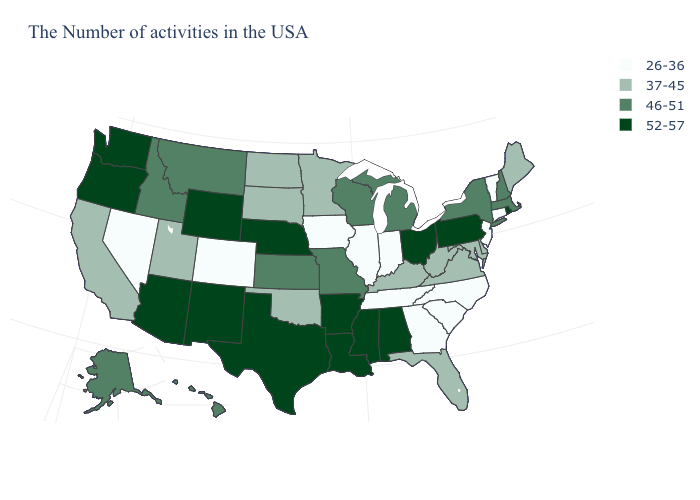What is the value of Wisconsin?
Keep it brief. 46-51. Does Maine have the same value as Kentucky?
Give a very brief answer. Yes. Does Nevada have the lowest value in the USA?
Quick response, please. Yes. What is the highest value in the MidWest ?
Keep it brief. 52-57. What is the value of Delaware?
Quick response, please. 37-45. Name the states that have a value in the range 52-57?
Short answer required. Rhode Island, Pennsylvania, Ohio, Alabama, Mississippi, Louisiana, Arkansas, Nebraska, Texas, Wyoming, New Mexico, Arizona, Washington, Oregon. What is the value of Illinois?
Concise answer only. 26-36. What is the value of Iowa?
Give a very brief answer. 26-36. What is the value of Virginia?
Keep it brief. 37-45. Does the first symbol in the legend represent the smallest category?
Be succinct. Yes. Name the states that have a value in the range 37-45?
Keep it brief. Maine, Delaware, Maryland, Virginia, West Virginia, Florida, Kentucky, Minnesota, Oklahoma, South Dakota, North Dakota, Utah, California. What is the lowest value in the West?
Concise answer only. 26-36. What is the highest value in the South ?
Keep it brief. 52-57. What is the lowest value in the Northeast?
Be succinct. 26-36. Among the states that border Kentucky , does Illinois have the lowest value?
Write a very short answer. Yes. 